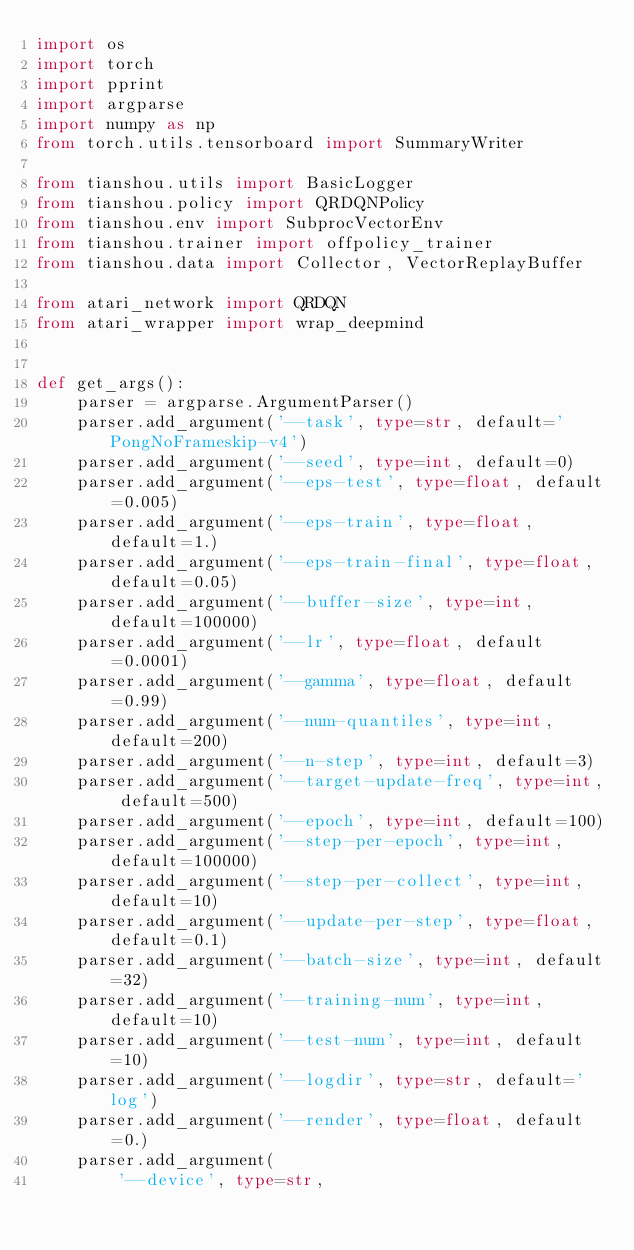Convert code to text. <code><loc_0><loc_0><loc_500><loc_500><_Python_>import os
import torch
import pprint
import argparse
import numpy as np
from torch.utils.tensorboard import SummaryWriter

from tianshou.utils import BasicLogger
from tianshou.policy import QRDQNPolicy
from tianshou.env import SubprocVectorEnv
from tianshou.trainer import offpolicy_trainer
from tianshou.data import Collector, VectorReplayBuffer

from atari_network import QRDQN
from atari_wrapper import wrap_deepmind


def get_args():
    parser = argparse.ArgumentParser()
    parser.add_argument('--task', type=str, default='PongNoFrameskip-v4')
    parser.add_argument('--seed', type=int, default=0)
    parser.add_argument('--eps-test', type=float, default=0.005)
    parser.add_argument('--eps-train', type=float, default=1.)
    parser.add_argument('--eps-train-final', type=float, default=0.05)
    parser.add_argument('--buffer-size', type=int, default=100000)
    parser.add_argument('--lr', type=float, default=0.0001)
    parser.add_argument('--gamma', type=float, default=0.99)
    parser.add_argument('--num-quantiles', type=int, default=200)
    parser.add_argument('--n-step', type=int, default=3)
    parser.add_argument('--target-update-freq', type=int, default=500)
    parser.add_argument('--epoch', type=int, default=100)
    parser.add_argument('--step-per-epoch', type=int, default=100000)
    parser.add_argument('--step-per-collect', type=int, default=10)
    parser.add_argument('--update-per-step', type=float, default=0.1)
    parser.add_argument('--batch-size', type=int, default=32)
    parser.add_argument('--training-num', type=int, default=10)
    parser.add_argument('--test-num', type=int, default=10)
    parser.add_argument('--logdir', type=str, default='log')
    parser.add_argument('--render', type=float, default=0.)
    parser.add_argument(
        '--device', type=str,</code> 